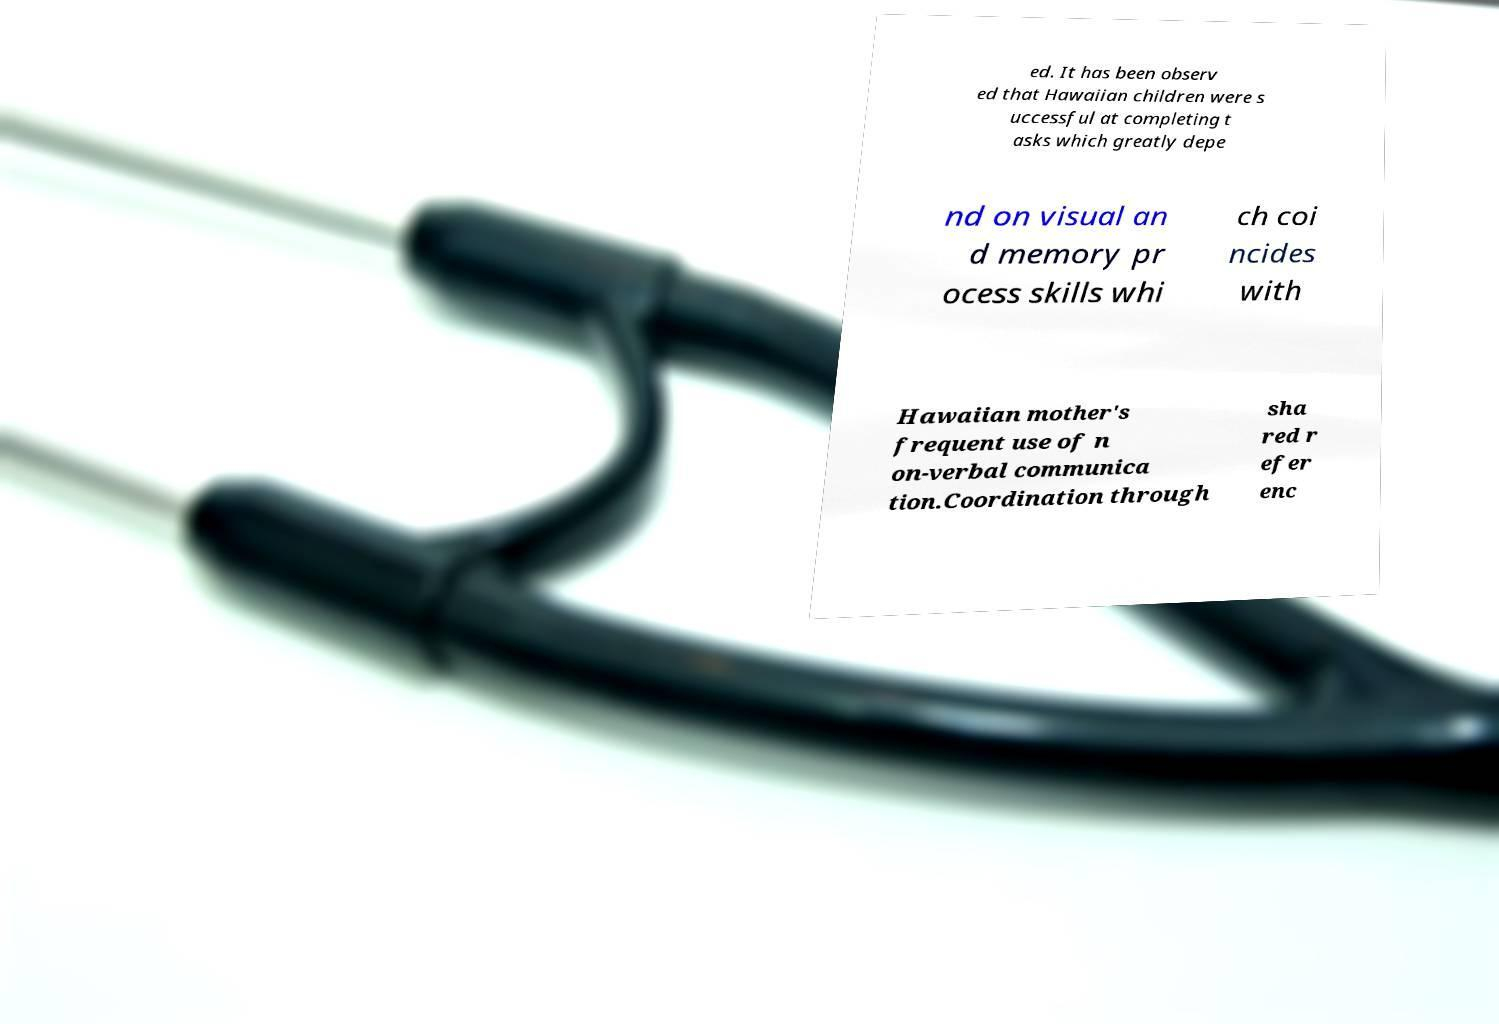Can you read and provide the text displayed in the image?This photo seems to have some interesting text. Can you extract and type it out for me? ed. It has been observ ed that Hawaiian children were s uccessful at completing t asks which greatly depe nd on visual an d memory pr ocess skills whi ch coi ncides with Hawaiian mother's frequent use of n on-verbal communica tion.Coordination through sha red r efer enc 